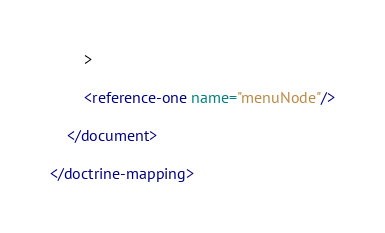<code> <loc_0><loc_0><loc_500><loc_500><_XML_>        >

        <reference-one name="menuNode"/>

    </document>

</doctrine-mapping>
</code> 